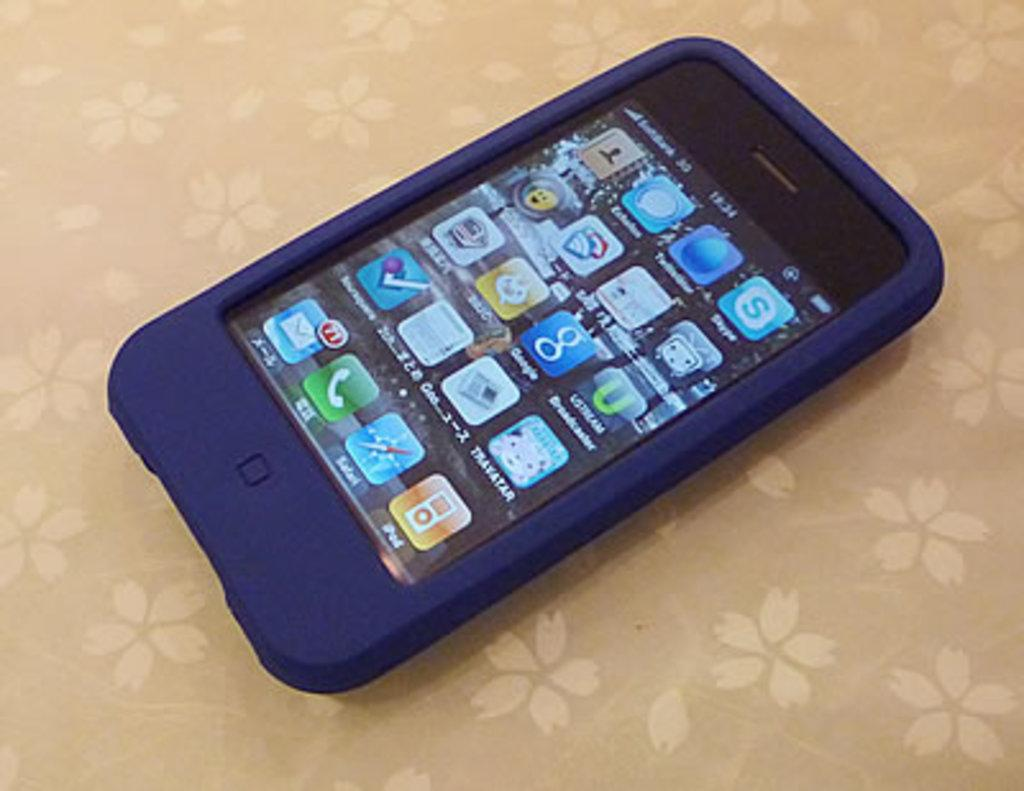Provide a one-sentence caption for the provided image. a cell phone in a blue rubber case with icons for Google on the display. 